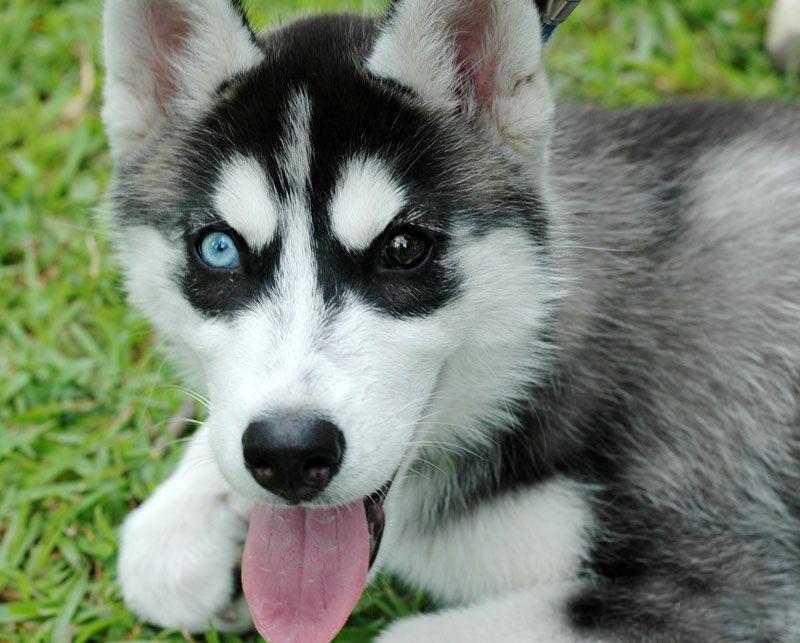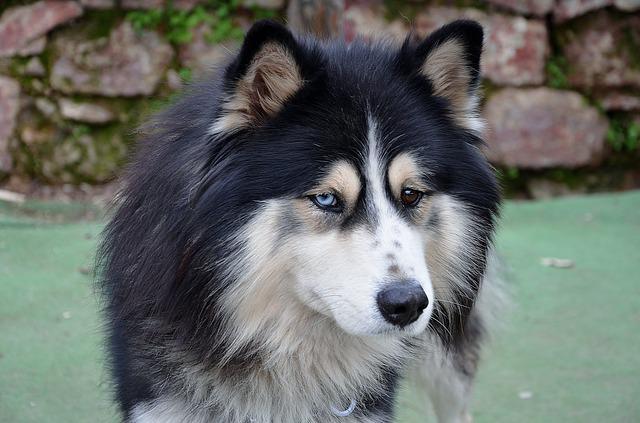The first image is the image on the left, the second image is the image on the right. Analyze the images presented: Is the assertion "One dog has its mouth open." valid? Answer yes or no. Yes. The first image is the image on the left, the second image is the image on the right. Given the left and right images, does the statement "The left and right image contains the same number of dogs with one puppy and one adult." hold true? Answer yes or no. Yes. 